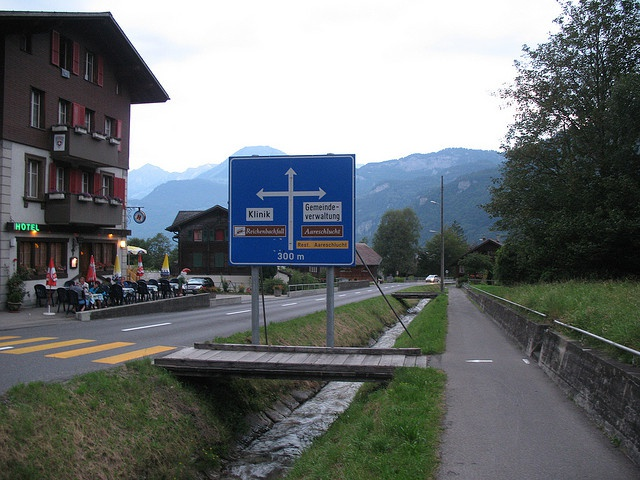Describe the objects in this image and their specific colors. I can see car in lavender, black, gray, and darkgray tones, umbrella in lavender, maroon, brown, gray, and black tones, chair in lavender, black, and gray tones, people in lavender, gray, black, and blue tones, and umbrella in lavender, black, olive, and gray tones in this image. 